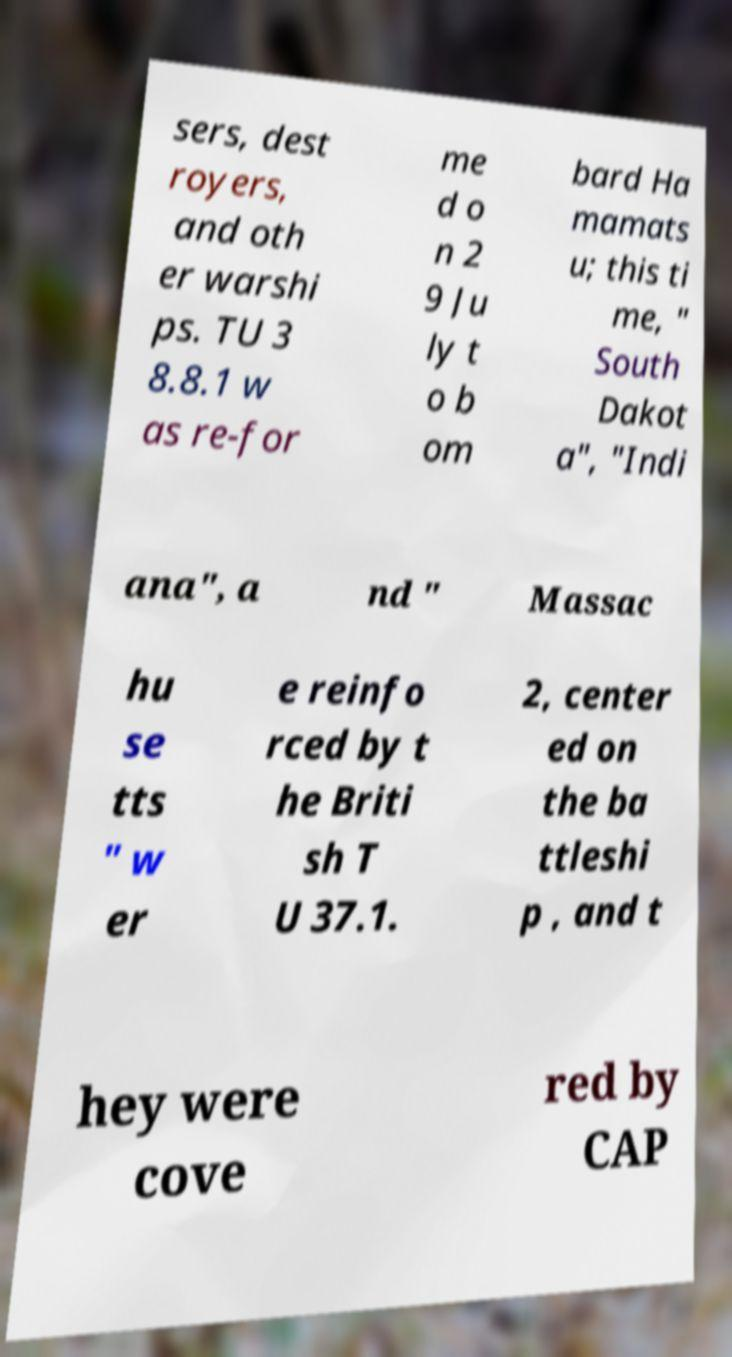Please read and relay the text visible in this image. What does it say? sers, dest royers, and oth er warshi ps. TU 3 8.8.1 w as re-for me d o n 2 9 Ju ly t o b om bard Ha mamats u; this ti me, " South Dakot a", "Indi ana", a nd " Massac hu se tts " w er e reinfo rced by t he Briti sh T U 37.1. 2, center ed on the ba ttleshi p , and t hey were cove red by CAP 